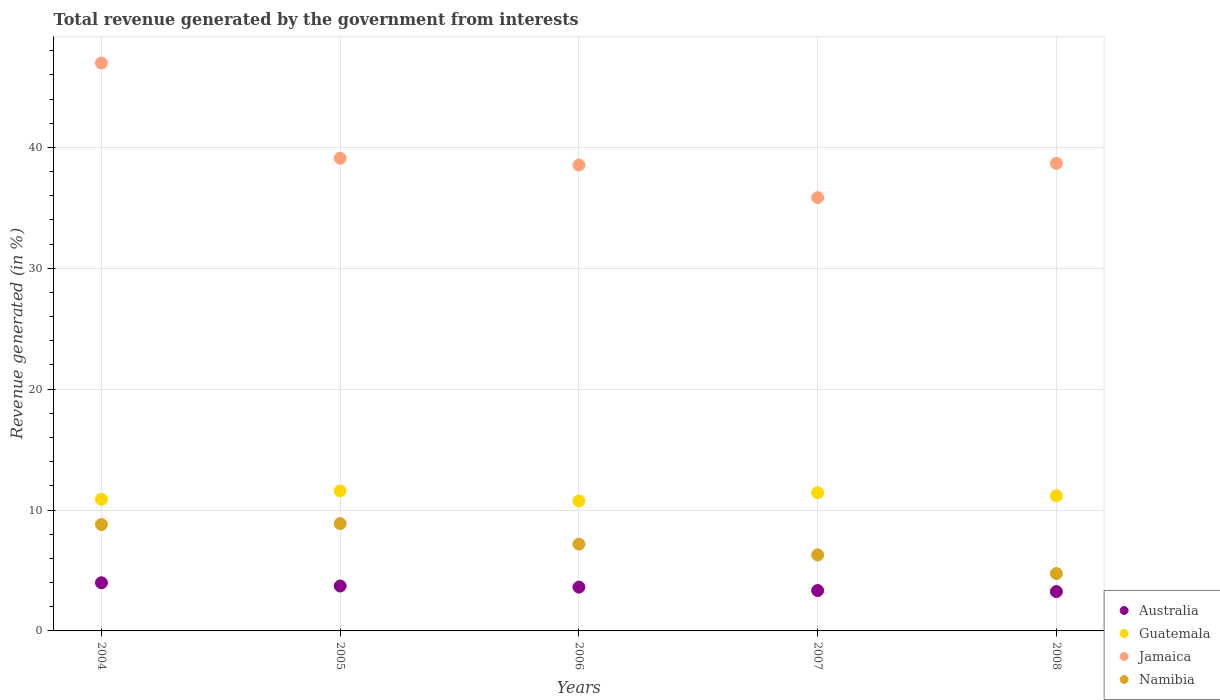Is the number of dotlines equal to the number of legend labels?
Offer a very short reply. Yes. What is the total revenue generated in Guatemala in 2007?
Your answer should be very brief. 11.43. Across all years, what is the maximum total revenue generated in Australia?
Your response must be concise. 3.98. Across all years, what is the minimum total revenue generated in Jamaica?
Keep it short and to the point. 35.84. In which year was the total revenue generated in Guatemala maximum?
Give a very brief answer. 2005. What is the total total revenue generated in Namibia in the graph?
Ensure brevity in your answer.  35.89. What is the difference between the total revenue generated in Guatemala in 2005 and that in 2006?
Your answer should be very brief. 0.83. What is the difference between the total revenue generated in Jamaica in 2006 and the total revenue generated in Australia in 2007?
Give a very brief answer. 35.2. What is the average total revenue generated in Jamaica per year?
Your response must be concise. 39.83. In the year 2004, what is the difference between the total revenue generated in Namibia and total revenue generated in Australia?
Provide a short and direct response. 4.82. What is the ratio of the total revenue generated in Jamaica in 2004 to that in 2008?
Keep it short and to the point. 1.21. Is the total revenue generated in Namibia in 2005 less than that in 2007?
Offer a terse response. No. What is the difference between the highest and the second highest total revenue generated in Jamaica?
Make the answer very short. 7.88. What is the difference between the highest and the lowest total revenue generated in Jamaica?
Your answer should be compact. 11.14. Does the total revenue generated in Jamaica monotonically increase over the years?
Your answer should be compact. No. Is the total revenue generated in Australia strictly greater than the total revenue generated in Jamaica over the years?
Your response must be concise. No. How many dotlines are there?
Ensure brevity in your answer.  4. How many years are there in the graph?
Offer a very short reply. 5. What is the difference between two consecutive major ticks on the Y-axis?
Offer a terse response. 10. Does the graph contain any zero values?
Give a very brief answer. No. Does the graph contain grids?
Your response must be concise. Yes. Where does the legend appear in the graph?
Offer a very short reply. Bottom right. What is the title of the graph?
Provide a succinct answer. Total revenue generated by the government from interests. Does "Saudi Arabia" appear as one of the legend labels in the graph?
Ensure brevity in your answer.  No. What is the label or title of the X-axis?
Your response must be concise. Years. What is the label or title of the Y-axis?
Offer a very short reply. Revenue generated (in %). What is the Revenue generated (in %) of Australia in 2004?
Provide a short and direct response. 3.98. What is the Revenue generated (in %) in Guatemala in 2004?
Keep it short and to the point. 10.89. What is the Revenue generated (in %) in Jamaica in 2004?
Your answer should be compact. 46.98. What is the Revenue generated (in %) in Namibia in 2004?
Give a very brief answer. 8.8. What is the Revenue generated (in %) in Australia in 2005?
Your answer should be compact. 3.71. What is the Revenue generated (in %) of Guatemala in 2005?
Give a very brief answer. 11.58. What is the Revenue generated (in %) in Jamaica in 2005?
Your answer should be compact. 39.1. What is the Revenue generated (in %) in Namibia in 2005?
Make the answer very short. 8.88. What is the Revenue generated (in %) in Australia in 2006?
Make the answer very short. 3.62. What is the Revenue generated (in %) of Guatemala in 2006?
Your response must be concise. 10.75. What is the Revenue generated (in %) in Jamaica in 2006?
Your answer should be very brief. 38.54. What is the Revenue generated (in %) in Namibia in 2006?
Make the answer very short. 7.18. What is the Revenue generated (in %) in Australia in 2007?
Make the answer very short. 3.34. What is the Revenue generated (in %) in Guatemala in 2007?
Your answer should be compact. 11.43. What is the Revenue generated (in %) of Jamaica in 2007?
Make the answer very short. 35.84. What is the Revenue generated (in %) of Namibia in 2007?
Your response must be concise. 6.29. What is the Revenue generated (in %) of Australia in 2008?
Give a very brief answer. 3.25. What is the Revenue generated (in %) in Guatemala in 2008?
Your answer should be very brief. 11.18. What is the Revenue generated (in %) of Jamaica in 2008?
Ensure brevity in your answer.  38.68. What is the Revenue generated (in %) in Namibia in 2008?
Your answer should be very brief. 4.75. Across all years, what is the maximum Revenue generated (in %) in Australia?
Your response must be concise. 3.98. Across all years, what is the maximum Revenue generated (in %) of Guatemala?
Provide a short and direct response. 11.58. Across all years, what is the maximum Revenue generated (in %) in Jamaica?
Offer a terse response. 46.98. Across all years, what is the maximum Revenue generated (in %) in Namibia?
Offer a very short reply. 8.88. Across all years, what is the minimum Revenue generated (in %) in Australia?
Keep it short and to the point. 3.25. Across all years, what is the minimum Revenue generated (in %) in Guatemala?
Provide a short and direct response. 10.75. Across all years, what is the minimum Revenue generated (in %) of Jamaica?
Your response must be concise. 35.84. Across all years, what is the minimum Revenue generated (in %) of Namibia?
Offer a terse response. 4.75. What is the total Revenue generated (in %) in Australia in the graph?
Your answer should be compact. 17.91. What is the total Revenue generated (in %) in Guatemala in the graph?
Ensure brevity in your answer.  55.83. What is the total Revenue generated (in %) of Jamaica in the graph?
Ensure brevity in your answer.  199.13. What is the total Revenue generated (in %) in Namibia in the graph?
Provide a short and direct response. 35.89. What is the difference between the Revenue generated (in %) in Australia in 2004 and that in 2005?
Offer a very short reply. 0.27. What is the difference between the Revenue generated (in %) of Guatemala in 2004 and that in 2005?
Your response must be concise. -0.69. What is the difference between the Revenue generated (in %) of Jamaica in 2004 and that in 2005?
Offer a very short reply. 7.88. What is the difference between the Revenue generated (in %) in Namibia in 2004 and that in 2005?
Provide a succinct answer. -0.08. What is the difference between the Revenue generated (in %) in Australia in 2004 and that in 2006?
Give a very brief answer. 0.36. What is the difference between the Revenue generated (in %) in Guatemala in 2004 and that in 2006?
Provide a short and direct response. 0.14. What is the difference between the Revenue generated (in %) of Jamaica in 2004 and that in 2006?
Provide a succinct answer. 8.44. What is the difference between the Revenue generated (in %) in Namibia in 2004 and that in 2006?
Provide a short and direct response. 1.62. What is the difference between the Revenue generated (in %) of Australia in 2004 and that in 2007?
Offer a terse response. 0.64. What is the difference between the Revenue generated (in %) in Guatemala in 2004 and that in 2007?
Your answer should be compact. -0.54. What is the difference between the Revenue generated (in %) of Jamaica in 2004 and that in 2007?
Make the answer very short. 11.14. What is the difference between the Revenue generated (in %) in Namibia in 2004 and that in 2007?
Give a very brief answer. 2.51. What is the difference between the Revenue generated (in %) of Australia in 2004 and that in 2008?
Your answer should be compact. 0.73. What is the difference between the Revenue generated (in %) of Guatemala in 2004 and that in 2008?
Offer a terse response. -0.29. What is the difference between the Revenue generated (in %) of Jamaica in 2004 and that in 2008?
Ensure brevity in your answer.  8.3. What is the difference between the Revenue generated (in %) of Namibia in 2004 and that in 2008?
Provide a succinct answer. 4.05. What is the difference between the Revenue generated (in %) in Australia in 2005 and that in 2006?
Keep it short and to the point. 0.09. What is the difference between the Revenue generated (in %) of Guatemala in 2005 and that in 2006?
Provide a short and direct response. 0.83. What is the difference between the Revenue generated (in %) of Jamaica in 2005 and that in 2006?
Offer a terse response. 0.56. What is the difference between the Revenue generated (in %) in Namibia in 2005 and that in 2006?
Your answer should be very brief. 1.69. What is the difference between the Revenue generated (in %) of Australia in 2005 and that in 2007?
Provide a succinct answer. 0.37. What is the difference between the Revenue generated (in %) of Guatemala in 2005 and that in 2007?
Keep it short and to the point. 0.15. What is the difference between the Revenue generated (in %) of Jamaica in 2005 and that in 2007?
Keep it short and to the point. 3.25. What is the difference between the Revenue generated (in %) in Namibia in 2005 and that in 2007?
Your response must be concise. 2.59. What is the difference between the Revenue generated (in %) in Australia in 2005 and that in 2008?
Provide a short and direct response. 0.46. What is the difference between the Revenue generated (in %) in Guatemala in 2005 and that in 2008?
Your answer should be compact. 0.41. What is the difference between the Revenue generated (in %) of Jamaica in 2005 and that in 2008?
Your answer should be compact. 0.42. What is the difference between the Revenue generated (in %) in Namibia in 2005 and that in 2008?
Offer a terse response. 4.13. What is the difference between the Revenue generated (in %) of Australia in 2006 and that in 2007?
Provide a short and direct response. 0.28. What is the difference between the Revenue generated (in %) in Guatemala in 2006 and that in 2007?
Offer a very short reply. -0.68. What is the difference between the Revenue generated (in %) of Jamaica in 2006 and that in 2007?
Ensure brevity in your answer.  2.7. What is the difference between the Revenue generated (in %) of Namibia in 2006 and that in 2007?
Your answer should be compact. 0.89. What is the difference between the Revenue generated (in %) of Australia in 2006 and that in 2008?
Offer a terse response. 0.37. What is the difference between the Revenue generated (in %) in Guatemala in 2006 and that in 2008?
Ensure brevity in your answer.  -0.43. What is the difference between the Revenue generated (in %) in Jamaica in 2006 and that in 2008?
Ensure brevity in your answer.  -0.14. What is the difference between the Revenue generated (in %) of Namibia in 2006 and that in 2008?
Make the answer very short. 2.44. What is the difference between the Revenue generated (in %) of Australia in 2007 and that in 2008?
Offer a very short reply. 0.09. What is the difference between the Revenue generated (in %) of Guatemala in 2007 and that in 2008?
Your response must be concise. 0.25. What is the difference between the Revenue generated (in %) in Jamaica in 2007 and that in 2008?
Offer a terse response. -2.83. What is the difference between the Revenue generated (in %) of Namibia in 2007 and that in 2008?
Your answer should be compact. 1.54. What is the difference between the Revenue generated (in %) of Australia in 2004 and the Revenue generated (in %) of Guatemala in 2005?
Give a very brief answer. -7.6. What is the difference between the Revenue generated (in %) in Australia in 2004 and the Revenue generated (in %) in Jamaica in 2005?
Your response must be concise. -35.11. What is the difference between the Revenue generated (in %) of Australia in 2004 and the Revenue generated (in %) of Namibia in 2005?
Provide a short and direct response. -4.89. What is the difference between the Revenue generated (in %) in Guatemala in 2004 and the Revenue generated (in %) in Jamaica in 2005?
Your answer should be compact. -28.21. What is the difference between the Revenue generated (in %) in Guatemala in 2004 and the Revenue generated (in %) in Namibia in 2005?
Your answer should be very brief. 2.01. What is the difference between the Revenue generated (in %) of Jamaica in 2004 and the Revenue generated (in %) of Namibia in 2005?
Give a very brief answer. 38.1. What is the difference between the Revenue generated (in %) of Australia in 2004 and the Revenue generated (in %) of Guatemala in 2006?
Make the answer very short. -6.77. What is the difference between the Revenue generated (in %) in Australia in 2004 and the Revenue generated (in %) in Jamaica in 2006?
Make the answer very short. -34.56. What is the difference between the Revenue generated (in %) of Australia in 2004 and the Revenue generated (in %) of Namibia in 2006?
Make the answer very short. -3.2. What is the difference between the Revenue generated (in %) in Guatemala in 2004 and the Revenue generated (in %) in Jamaica in 2006?
Offer a very short reply. -27.65. What is the difference between the Revenue generated (in %) in Guatemala in 2004 and the Revenue generated (in %) in Namibia in 2006?
Make the answer very short. 3.71. What is the difference between the Revenue generated (in %) of Jamaica in 2004 and the Revenue generated (in %) of Namibia in 2006?
Offer a very short reply. 39.8. What is the difference between the Revenue generated (in %) in Australia in 2004 and the Revenue generated (in %) in Guatemala in 2007?
Provide a short and direct response. -7.45. What is the difference between the Revenue generated (in %) of Australia in 2004 and the Revenue generated (in %) of Jamaica in 2007?
Offer a very short reply. -31.86. What is the difference between the Revenue generated (in %) in Australia in 2004 and the Revenue generated (in %) in Namibia in 2007?
Make the answer very short. -2.31. What is the difference between the Revenue generated (in %) of Guatemala in 2004 and the Revenue generated (in %) of Jamaica in 2007?
Offer a terse response. -24.95. What is the difference between the Revenue generated (in %) in Guatemala in 2004 and the Revenue generated (in %) in Namibia in 2007?
Make the answer very short. 4.6. What is the difference between the Revenue generated (in %) in Jamaica in 2004 and the Revenue generated (in %) in Namibia in 2007?
Your answer should be compact. 40.69. What is the difference between the Revenue generated (in %) in Australia in 2004 and the Revenue generated (in %) in Guatemala in 2008?
Provide a succinct answer. -7.19. What is the difference between the Revenue generated (in %) of Australia in 2004 and the Revenue generated (in %) of Jamaica in 2008?
Ensure brevity in your answer.  -34.69. What is the difference between the Revenue generated (in %) in Australia in 2004 and the Revenue generated (in %) in Namibia in 2008?
Your response must be concise. -0.76. What is the difference between the Revenue generated (in %) of Guatemala in 2004 and the Revenue generated (in %) of Jamaica in 2008?
Your response must be concise. -27.79. What is the difference between the Revenue generated (in %) of Guatemala in 2004 and the Revenue generated (in %) of Namibia in 2008?
Your answer should be compact. 6.15. What is the difference between the Revenue generated (in %) in Jamaica in 2004 and the Revenue generated (in %) in Namibia in 2008?
Keep it short and to the point. 42.23. What is the difference between the Revenue generated (in %) of Australia in 2005 and the Revenue generated (in %) of Guatemala in 2006?
Your answer should be very brief. -7.03. What is the difference between the Revenue generated (in %) of Australia in 2005 and the Revenue generated (in %) of Jamaica in 2006?
Your answer should be compact. -34.83. What is the difference between the Revenue generated (in %) of Australia in 2005 and the Revenue generated (in %) of Namibia in 2006?
Ensure brevity in your answer.  -3.47. What is the difference between the Revenue generated (in %) of Guatemala in 2005 and the Revenue generated (in %) of Jamaica in 2006?
Offer a very short reply. -26.96. What is the difference between the Revenue generated (in %) in Guatemala in 2005 and the Revenue generated (in %) in Namibia in 2006?
Offer a very short reply. 4.4. What is the difference between the Revenue generated (in %) in Jamaica in 2005 and the Revenue generated (in %) in Namibia in 2006?
Give a very brief answer. 31.91. What is the difference between the Revenue generated (in %) in Australia in 2005 and the Revenue generated (in %) in Guatemala in 2007?
Keep it short and to the point. -7.71. What is the difference between the Revenue generated (in %) of Australia in 2005 and the Revenue generated (in %) of Jamaica in 2007?
Provide a short and direct response. -32.13. What is the difference between the Revenue generated (in %) of Australia in 2005 and the Revenue generated (in %) of Namibia in 2007?
Your response must be concise. -2.57. What is the difference between the Revenue generated (in %) of Guatemala in 2005 and the Revenue generated (in %) of Jamaica in 2007?
Offer a terse response. -24.26. What is the difference between the Revenue generated (in %) in Guatemala in 2005 and the Revenue generated (in %) in Namibia in 2007?
Your response must be concise. 5.3. What is the difference between the Revenue generated (in %) of Jamaica in 2005 and the Revenue generated (in %) of Namibia in 2007?
Ensure brevity in your answer.  32.81. What is the difference between the Revenue generated (in %) in Australia in 2005 and the Revenue generated (in %) in Guatemala in 2008?
Keep it short and to the point. -7.46. What is the difference between the Revenue generated (in %) in Australia in 2005 and the Revenue generated (in %) in Jamaica in 2008?
Offer a terse response. -34.96. What is the difference between the Revenue generated (in %) in Australia in 2005 and the Revenue generated (in %) in Namibia in 2008?
Provide a short and direct response. -1.03. What is the difference between the Revenue generated (in %) of Guatemala in 2005 and the Revenue generated (in %) of Jamaica in 2008?
Make the answer very short. -27.09. What is the difference between the Revenue generated (in %) of Guatemala in 2005 and the Revenue generated (in %) of Namibia in 2008?
Your answer should be compact. 6.84. What is the difference between the Revenue generated (in %) of Jamaica in 2005 and the Revenue generated (in %) of Namibia in 2008?
Your answer should be very brief. 34.35. What is the difference between the Revenue generated (in %) of Australia in 2006 and the Revenue generated (in %) of Guatemala in 2007?
Make the answer very short. -7.81. What is the difference between the Revenue generated (in %) of Australia in 2006 and the Revenue generated (in %) of Jamaica in 2007?
Provide a short and direct response. -32.22. What is the difference between the Revenue generated (in %) in Australia in 2006 and the Revenue generated (in %) in Namibia in 2007?
Keep it short and to the point. -2.66. What is the difference between the Revenue generated (in %) in Guatemala in 2006 and the Revenue generated (in %) in Jamaica in 2007?
Your answer should be compact. -25.09. What is the difference between the Revenue generated (in %) in Guatemala in 2006 and the Revenue generated (in %) in Namibia in 2007?
Provide a short and direct response. 4.46. What is the difference between the Revenue generated (in %) of Jamaica in 2006 and the Revenue generated (in %) of Namibia in 2007?
Offer a very short reply. 32.25. What is the difference between the Revenue generated (in %) of Australia in 2006 and the Revenue generated (in %) of Guatemala in 2008?
Offer a very short reply. -7.55. What is the difference between the Revenue generated (in %) in Australia in 2006 and the Revenue generated (in %) in Jamaica in 2008?
Give a very brief answer. -35.05. What is the difference between the Revenue generated (in %) of Australia in 2006 and the Revenue generated (in %) of Namibia in 2008?
Offer a terse response. -1.12. What is the difference between the Revenue generated (in %) of Guatemala in 2006 and the Revenue generated (in %) of Jamaica in 2008?
Provide a succinct answer. -27.93. What is the difference between the Revenue generated (in %) of Guatemala in 2006 and the Revenue generated (in %) of Namibia in 2008?
Make the answer very short. 6. What is the difference between the Revenue generated (in %) in Jamaica in 2006 and the Revenue generated (in %) in Namibia in 2008?
Your answer should be compact. 33.8. What is the difference between the Revenue generated (in %) of Australia in 2007 and the Revenue generated (in %) of Guatemala in 2008?
Your answer should be very brief. -7.84. What is the difference between the Revenue generated (in %) of Australia in 2007 and the Revenue generated (in %) of Jamaica in 2008?
Your response must be concise. -35.34. What is the difference between the Revenue generated (in %) of Australia in 2007 and the Revenue generated (in %) of Namibia in 2008?
Make the answer very short. -1.41. What is the difference between the Revenue generated (in %) of Guatemala in 2007 and the Revenue generated (in %) of Jamaica in 2008?
Offer a very short reply. -27.25. What is the difference between the Revenue generated (in %) of Guatemala in 2007 and the Revenue generated (in %) of Namibia in 2008?
Provide a succinct answer. 6.68. What is the difference between the Revenue generated (in %) in Jamaica in 2007 and the Revenue generated (in %) in Namibia in 2008?
Provide a short and direct response. 31.1. What is the average Revenue generated (in %) in Australia per year?
Keep it short and to the point. 3.58. What is the average Revenue generated (in %) in Guatemala per year?
Offer a very short reply. 11.17. What is the average Revenue generated (in %) in Jamaica per year?
Your response must be concise. 39.83. What is the average Revenue generated (in %) of Namibia per year?
Your answer should be very brief. 7.18. In the year 2004, what is the difference between the Revenue generated (in %) of Australia and Revenue generated (in %) of Guatemala?
Provide a short and direct response. -6.91. In the year 2004, what is the difference between the Revenue generated (in %) in Australia and Revenue generated (in %) in Jamaica?
Your answer should be very brief. -43. In the year 2004, what is the difference between the Revenue generated (in %) in Australia and Revenue generated (in %) in Namibia?
Make the answer very short. -4.82. In the year 2004, what is the difference between the Revenue generated (in %) in Guatemala and Revenue generated (in %) in Jamaica?
Offer a very short reply. -36.09. In the year 2004, what is the difference between the Revenue generated (in %) in Guatemala and Revenue generated (in %) in Namibia?
Give a very brief answer. 2.09. In the year 2004, what is the difference between the Revenue generated (in %) of Jamaica and Revenue generated (in %) of Namibia?
Keep it short and to the point. 38.18. In the year 2005, what is the difference between the Revenue generated (in %) in Australia and Revenue generated (in %) in Guatemala?
Make the answer very short. -7.87. In the year 2005, what is the difference between the Revenue generated (in %) in Australia and Revenue generated (in %) in Jamaica?
Ensure brevity in your answer.  -35.38. In the year 2005, what is the difference between the Revenue generated (in %) of Australia and Revenue generated (in %) of Namibia?
Your answer should be very brief. -5.16. In the year 2005, what is the difference between the Revenue generated (in %) in Guatemala and Revenue generated (in %) in Jamaica?
Offer a very short reply. -27.51. In the year 2005, what is the difference between the Revenue generated (in %) of Guatemala and Revenue generated (in %) of Namibia?
Your answer should be very brief. 2.71. In the year 2005, what is the difference between the Revenue generated (in %) in Jamaica and Revenue generated (in %) in Namibia?
Keep it short and to the point. 30.22. In the year 2006, what is the difference between the Revenue generated (in %) in Australia and Revenue generated (in %) in Guatemala?
Provide a short and direct response. -7.13. In the year 2006, what is the difference between the Revenue generated (in %) of Australia and Revenue generated (in %) of Jamaica?
Give a very brief answer. -34.92. In the year 2006, what is the difference between the Revenue generated (in %) of Australia and Revenue generated (in %) of Namibia?
Give a very brief answer. -3.56. In the year 2006, what is the difference between the Revenue generated (in %) of Guatemala and Revenue generated (in %) of Jamaica?
Your answer should be compact. -27.79. In the year 2006, what is the difference between the Revenue generated (in %) in Guatemala and Revenue generated (in %) in Namibia?
Your answer should be compact. 3.57. In the year 2006, what is the difference between the Revenue generated (in %) in Jamaica and Revenue generated (in %) in Namibia?
Give a very brief answer. 31.36. In the year 2007, what is the difference between the Revenue generated (in %) in Australia and Revenue generated (in %) in Guatemala?
Ensure brevity in your answer.  -8.09. In the year 2007, what is the difference between the Revenue generated (in %) in Australia and Revenue generated (in %) in Jamaica?
Keep it short and to the point. -32.5. In the year 2007, what is the difference between the Revenue generated (in %) in Australia and Revenue generated (in %) in Namibia?
Give a very brief answer. -2.95. In the year 2007, what is the difference between the Revenue generated (in %) in Guatemala and Revenue generated (in %) in Jamaica?
Your answer should be compact. -24.41. In the year 2007, what is the difference between the Revenue generated (in %) in Guatemala and Revenue generated (in %) in Namibia?
Provide a short and direct response. 5.14. In the year 2007, what is the difference between the Revenue generated (in %) in Jamaica and Revenue generated (in %) in Namibia?
Offer a terse response. 29.55. In the year 2008, what is the difference between the Revenue generated (in %) in Australia and Revenue generated (in %) in Guatemala?
Offer a terse response. -7.92. In the year 2008, what is the difference between the Revenue generated (in %) in Australia and Revenue generated (in %) in Jamaica?
Your response must be concise. -35.42. In the year 2008, what is the difference between the Revenue generated (in %) of Australia and Revenue generated (in %) of Namibia?
Provide a short and direct response. -1.49. In the year 2008, what is the difference between the Revenue generated (in %) in Guatemala and Revenue generated (in %) in Jamaica?
Your response must be concise. -27.5. In the year 2008, what is the difference between the Revenue generated (in %) of Guatemala and Revenue generated (in %) of Namibia?
Provide a succinct answer. 6.43. In the year 2008, what is the difference between the Revenue generated (in %) in Jamaica and Revenue generated (in %) in Namibia?
Offer a very short reply. 33.93. What is the ratio of the Revenue generated (in %) of Australia in 2004 to that in 2005?
Provide a short and direct response. 1.07. What is the ratio of the Revenue generated (in %) of Guatemala in 2004 to that in 2005?
Your response must be concise. 0.94. What is the ratio of the Revenue generated (in %) of Jamaica in 2004 to that in 2005?
Ensure brevity in your answer.  1.2. What is the ratio of the Revenue generated (in %) of Australia in 2004 to that in 2006?
Your answer should be compact. 1.1. What is the ratio of the Revenue generated (in %) in Guatemala in 2004 to that in 2006?
Keep it short and to the point. 1.01. What is the ratio of the Revenue generated (in %) in Jamaica in 2004 to that in 2006?
Ensure brevity in your answer.  1.22. What is the ratio of the Revenue generated (in %) of Namibia in 2004 to that in 2006?
Offer a very short reply. 1.23. What is the ratio of the Revenue generated (in %) in Australia in 2004 to that in 2007?
Provide a succinct answer. 1.19. What is the ratio of the Revenue generated (in %) of Guatemala in 2004 to that in 2007?
Offer a terse response. 0.95. What is the ratio of the Revenue generated (in %) in Jamaica in 2004 to that in 2007?
Make the answer very short. 1.31. What is the ratio of the Revenue generated (in %) in Namibia in 2004 to that in 2007?
Your answer should be very brief. 1.4. What is the ratio of the Revenue generated (in %) in Australia in 2004 to that in 2008?
Keep it short and to the point. 1.22. What is the ratio of the Revenue generated (in %) in Guatemala in 2004 to that in 2008?
Give a very brief answer. 0.97. What is the ratio of the Revenue generated (in %) of Jamaica in 2004 to that in 2008?
Give a very brief answer. 1.21. What is the ratio of the Revenue generated (in %) in Namibia in 2004 to that in 2008?
Offer a very short reply. 1.85. What is the ratio of the Revenue generated (in %) of Australia in 2005 to that in 2006?
Keep it short and to the point. 1.03. What is the ratio of the Revenue generated (in %) in Guatemala in 2005 to that in 2006?
Your answer should be compact. 1.08. What is the ratio of the Revenue generated (in %) in Jamaica in 2005 to that in 2006?
Your answer should be very brief. 1.01. What is the ratio of the Revenue generated (in %) of Namibia in 2005 to that in 2006?
Your answer should be very brief. 1.24. What is the ratio of the Revenue generated (in %) of Australia in 2005 to that in 2007?
Ensure brevity in your answer.  1.11. What is the ratio of the Revenue generated (in %) of Guatemala in 2005 to that in 2007?
Provide a short and direct response. 1.01. What is the ratio of the Revenue generated (in %) of Jamaica in 2005 to that in 2007?
Make the answer very short. 1.09. What is the ratio of the Revenue generated (in %) in Namibia in 2005 to that in 2007?
Offer a very short reply. 1.41. What is the ratio of the Revenue generated (in %) of Australia in 2005 to that in 2008?
Ensure brevity in your answer.  1.14. What is the ratio of the Revenue generated (in %) in Guatemala in 2005 to that in 2008?
Your answer should be very brief. 1.04. What is the ratio of the Revenue generated (in %) in Jamaica in 2005 to that in 2008?
Offer a very short reply. 1.01. What is the ratio of the Revenue generated (in %) in Namibia in 2005 to that in 2008?
Your response must be concise. 1.87. What is the ratio of the Revenue generated (in %) of Australia in 2006 to that in 2007?
Provide a short and direct response. 1.08. What is the ratio of the Revenue generated (in %) of Guatemala in 2006 to that in 2007?
Your response must be concise. 0.94. What is the ratio of the Revenue generated (in %) of Jamaica in 2006 to that in 2007?
Keep it short and to the point. 1.08. What is the ratio of the Revenue generated (in %) of Namibia in 2006 to that in 2007?
Your answer should be compact. 1.14. What is the ratio of the Revenue generated (in %) of Australia in 2006 to that in 2008?
Ensure brevity in your answer.  1.11. What is the ratio of the Revenue generated (in %) of Guatemala in 2006 to that in 2008?
Your answer should be compact. 0.96. What is the ratio of the Revenue generated (in %) of Jamaica in 2006 to that in 2008?
Offer a terse response. 1. What is the ratio of the Revenue generated (in %) in Namibia in 2006 to that in 2008?
Provide a succinct answer. 1.51. What is the ratio of the Revenue generated (in %) of Australia in 2007 to that in 2008?
Offer a terse response. 1.03. What is the ratio of the Revenue generated (in %) in Guatemala in 2007 to that in 2008?
Give a very brief answer. 1.02. What is the ratio of the Revenue generated (in %) of Jamaica in 2007 to that in 2008?
Make the answer very short. 0.93. What is the ratio of the Revenue generated (in %) of Namibia in 2007 to that in 2008?
Provide a succinct answer. 1.33. What is the difference between the highest and the second highest Revenue generated (in %) in Australia?
Give a very brief answer. 0.27. What is the difference between the highest and the second highest Revenue generated (in %) of Guatemala?
Ensure brevity in your answer.  0.15. What is the difference between the highest and the second highest Revenue generated (in %) in Jamaica?
Provide a short and direct response. 7.88. What is the difference between the highest and the second highest Revenue generated (in %) in Namibia?
Your response must be concise. 0.08. What is the difference between the highest and the lowest Revenue generated (in %) of Australia?
Make the answer very short. 0.73. What is the difference between the highest and the lowest Revenue generated (in %) in Guatemala?
Your answer should be very brief. 0.83. What is the difference between the highest and the lowest Revenue generated (in %) in Jamaica?
Keep it short and to the point. 11.14. What is the difference between the highest and the lowest Revenue generated (in %) of Namibia?
Provide a short and direct response. 4.13. 